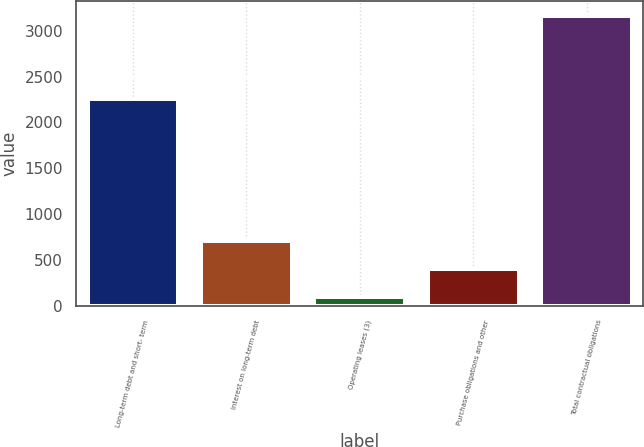Convert chart. <chart><loc_0><loc_0><loc_500><loc_500><bar_chart><fcel>Long-term debt and short- term<fcel>Interest on long-term debt<fcel>Operating leases (3)<fcel>Purchase obligations and other<fcel>Total contractual obligations<nl><fcel>2259<fcel>711.6<fcel>99<fcel>405.3<fcel>3162<nl></chart> 